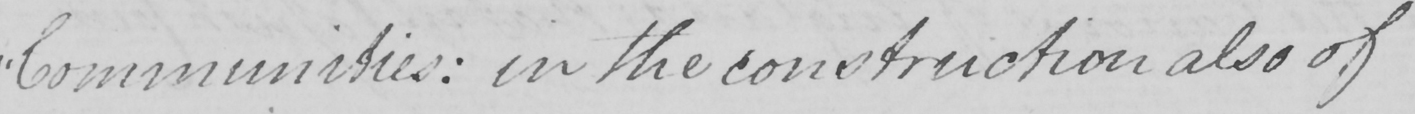Can you read and transcribe this handwriting? " Communities :  in the construction also of 